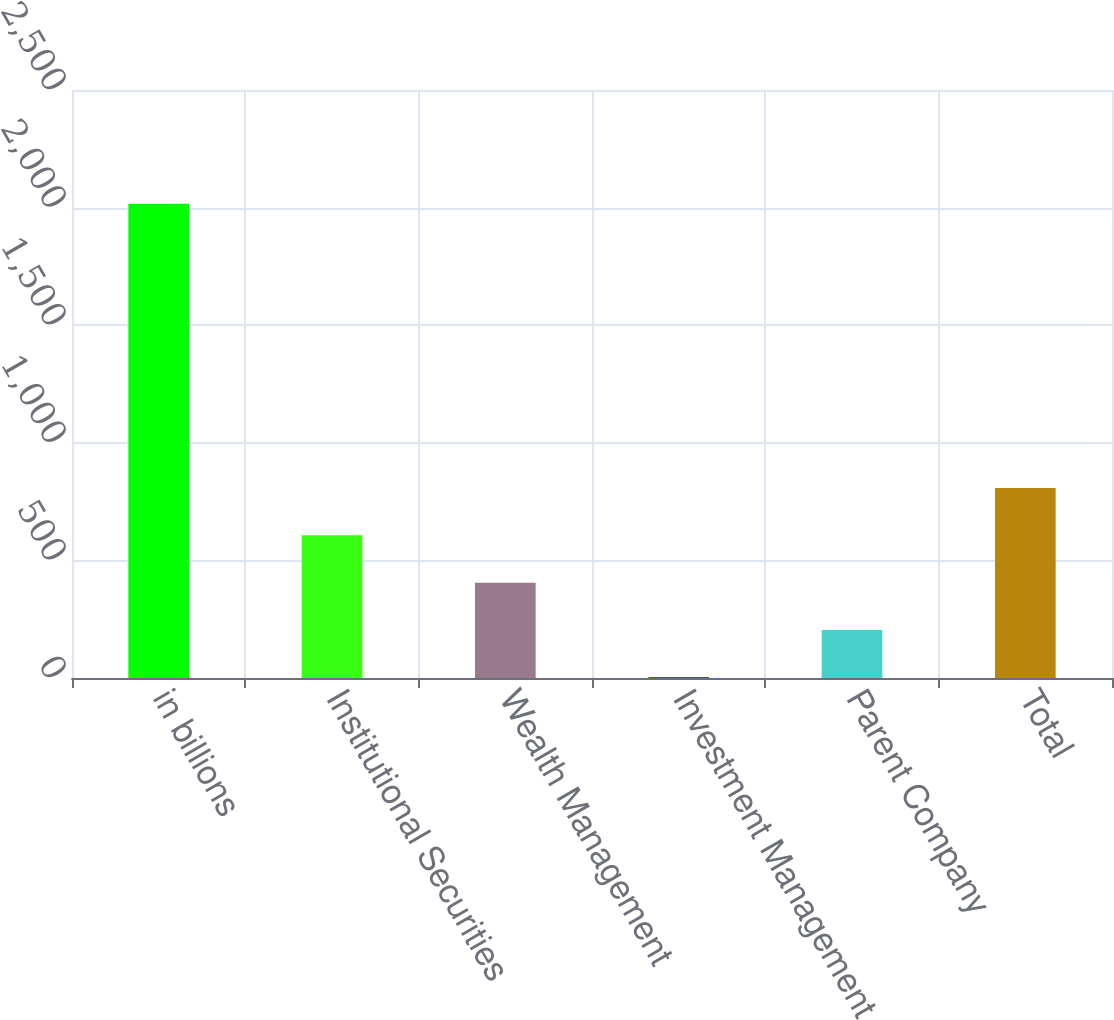Convert chart to OTSL. <chart><loc_0><loc_0><loc_500><loc_500><bar_chart><fcel>in billions<fcel>Institutional Securities<fcel>Wealth Management<fcel>Investment Management<fcel>Parent Company<fcel>Total<nl><fcel>2016<fcel>606.76<fcel>405.44<fcel>2.8<fcel>204.12<fcel>808.08<nl></chart> 